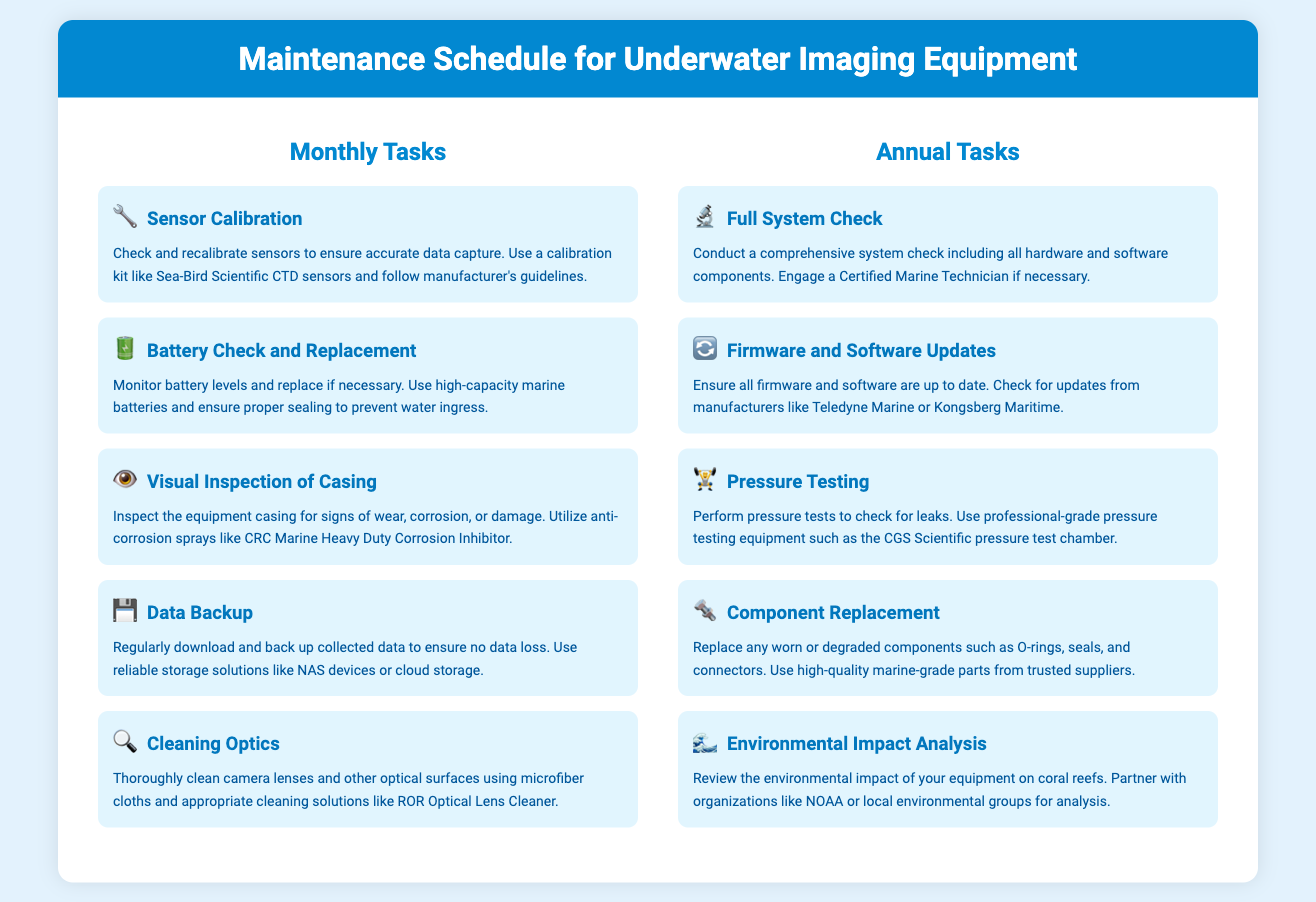what is the first monthly task? The first monthly task listed in the infographic is Sensor Calibration.
Answer: Sensor Calibration how often should the battery be checked? The infographic indicates that battery levels should be monitored monthly.
Answer: Monthly what equipment is recommended for pressure testing? The document suggests using the CGS Scientific pressure test chamber for pressure testing.
Answer: CGS Scientific pressure test chamber what is the main focus of the annual Environmental Impact Analysis task? The Environmental Impact Analysis task focuses on reviewing the impact of equipment on coral reefs.
Answer: Coral reefs how many tasks are listed under annual maintenance? There are five tasks listed under annual maintenance.
Answer: Five which company should be checked for firmware updates? The infographic recommends checking for updates from Teledyne Marine.
Answer: Teledyne Marine what type of cloth is suggested for cleaning optics? The suggested type of cloth for cleaning optics is microfiber cloths.
Answer: Microfiber cloths is component replacement a monthly or annual task? Component Replacement is categorized as an annual task in the document.
Answer: Annual what is used for anti-corrosion during visual inspection? The document mentions using CRC Marine Heavy Duty Corrosion Inhibitor for anti-corrosion.
Answer: CRC Marine Heavy Duty Corrosion Inhibitor 